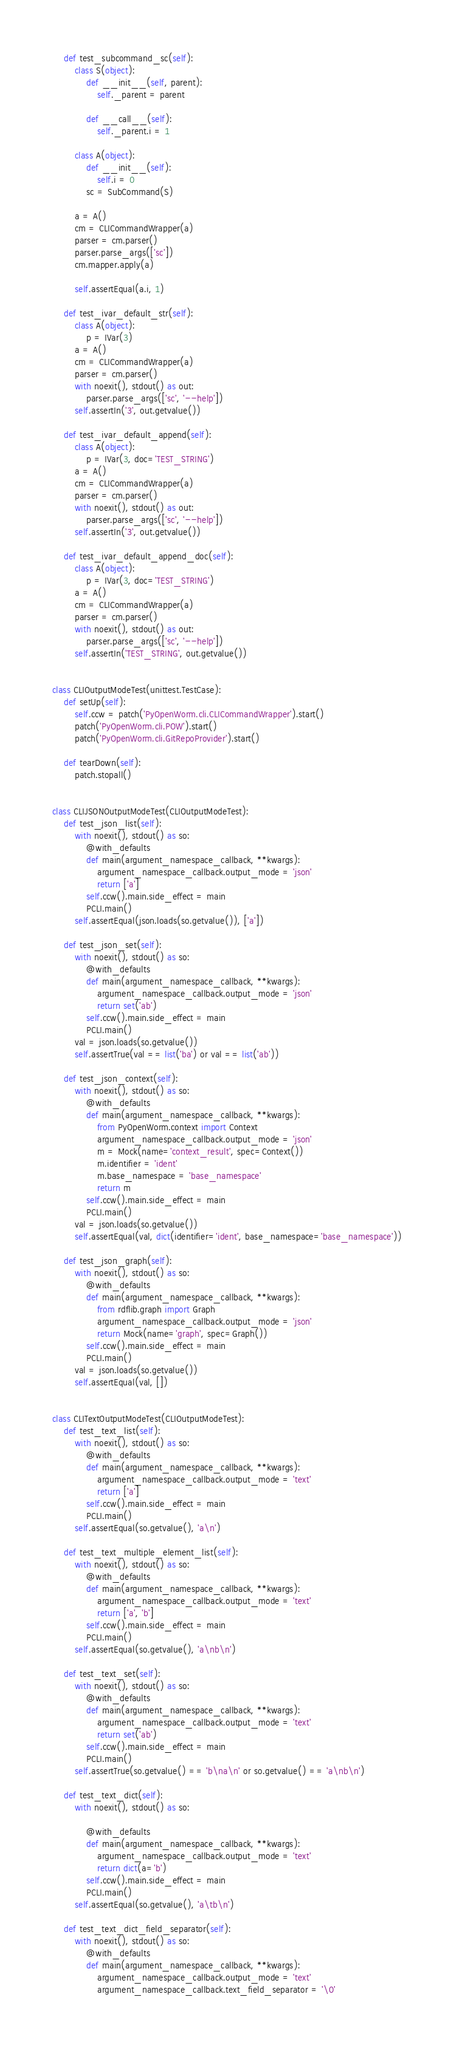Convert code to text. <code><loc_0><loc_0><loc_500><loc_500><_Python_>    def test_subcommand_sc(self):
        class S(object):
            def __init__(self, parent):
                self._parent = parent

            def __call__(self):
                self._parent.i = 1

        class A(object):
            def __init__(self):
                self.i = 0
            sc = SubCommand(S)

        a = A()
        cm = CLICommandWrapper(a)
        parser = cm.parser()
        parser.parse_args(['sc'])
        cm.mapper.apply(a)

        self.assertEqual(a.i, 1)

    def test_ivar_default_str(self):
        class A(object):
            p = IVar(3)
        a = A()
        cm = CLICommandWrapper(a)
        parser = cm.parser()
        with noexit(), stdout() as out:
            parser.parse_args(['sc', '--help'])
        self.assertIn('3', out.getvalue())

    def test_ivar_default_append(self):
        class A(object):
            p = IVar(3, doc='TEST_STRING')
        a = A()
        cm = CLICommandWrapper(a)
        parser = cm.parser()
        with noexit(), stdout() as out:
            parser.parse_args(['sc', '--help'])
        self.assertIn('3', out.getvalue())

    def test_ivar_default_append_doc(self):
        class A(object):
            p = IVar(3, doc='TEST_STRING')
        a = A()
        cm = CLICommandWrapper(a)
        parser = cm.parser()
        with noexit(), stdout() as out:
            parser.parse_args(['sc', '--help'])
        self.assertIn('TEST_STRING', out.getvalue())


class CLIOutputModeTest(unittest.TestCase):
    def setUp(self):
        self.ccw = patch('PyOpenWorm.cli.CLICommandWrapper').start()
        patch('PyOpenWorm.cli.POW').start()
        patch('PyOpenWorm.cli.GitRepoProvider').start()

    def tearDown(self):
        patch.stopall()


class CLIJSONOutputModeTest(CLIOutputModeTest):
    def test_json_list(self):
        with noexit(), stdout() as so:
            @with_defaults
            def main(argument_namespace_callback, **kwargs):
                argument_namespace_callback.output_mode = 'json'
                return ['a']
            self.ccw().main.side_effect = main
            PCLI.main()
        self.assertEqual(json.loads(so.getvalue()), ['a'])

    def test_json_set(self):
        with noexit(), stdout() as so:
            @with_defaults
            def main(argument_namespace_callback, **kwargs):
                argument_namespace_callback.output_mode = 'json'
                return set('ab')
            self.ccw().main.side_effect = main
            PCLI.main()
        val = json.loads(so.getvalue())
        self.assertTrue(val == list('ba') or val == list('ab'))

    def test_json_context(self):
        with noexit(), stdout() as so:
            @with_defaults
            def main(argument_namespace_callback, **kwargs):
                from PyOpenWorm.context import Context
                argument_namespace_callback.output_mode = 'json'
                m = Mock(name='context_result', spec=Context())
                m.identifier = 'ident'
                m.base_namespace = 'base_namespace'
                return m
            self.ccw().main.side_effect = main
            PCLI.main()
        val = json.loads(so.getvalue())
        self.assertEqual(val, dict(identifier='ident', base_namespace='base_namespace'))

    def test_json_graph(self):
        with noexit(), stdout() as so:
            @with_defaults
            def main(argument_namespace_callback, **kwargs):
                from rdflib.graph import Graph
                argument_namespace_callback.output_mode = 'json'
                return Mock(name='graph', spec=Graph())
            self.ccw().main.side_effect = main
            PCLI.main()
        val = json.loads(so.getvalue())
        self.assertEqual(val, [])


class CLITextOutputModeTest(CLIOutputModeTest):
    def test_text_list(self):
        with noexit(), stdout() as so:
            @with_defaults
            def main(argument_namespace_callback, **kwargs):
                argument_namespace_callback.output_mode = 'text'
                return ['a']
            self.ccw().main.side_effect = main
            PCLI.main()
        self.assertEqual(so.getvalue(), 'a\n')

    def test_text_multiple_element_list(self):
        with noexit(), stdout() as so:
            @with_defaults
            def main(argument_namespace_callback, **kwargs):
                argument_namespace_callback.output_mode = 'text'
                return ['a', 'b']
            self.ccw().main.side_effect = main
            PCLI.main()
        self.assertEqual(so.getvalue(), 'a\nb\n')

    def test_text_set(self):
        with noexit(), stdout() as so:
            @with_defaults
            def main(argument_namespace_callback, **kwargs):
                argument_namespace_callback.output_mode = 'text'
                return set('ab')
            self.ccw().main.side_effect = main
            PCLI.main()
        self.assertTrue(so.getvalue() == 'b\na\n' or so.getvalue() == 'a\nb\n')

    def test_text_dict(self):
        with noexit(), stdout() as so:

            @with_defaults
            def main(argument_namespace_callback, **kwargs):
                argument_namespace_callback.output_mode = 'text'
                return dict(a='b')
            self.ccw().main.side_effect = main
            PCLI.main()
        self.assertEqual(so.getvalue(), 'a\tb\n')

    def test_text_dict_field_separator(self):
        with noexit(), stdout() as so:
            @with_defaults
            def main(argument_namespace_callback, **kwargs):
                argument_namespace_callback.output_mode = 'text'
                argument_namespace_callback.text_field_separator = '\0'</code> 